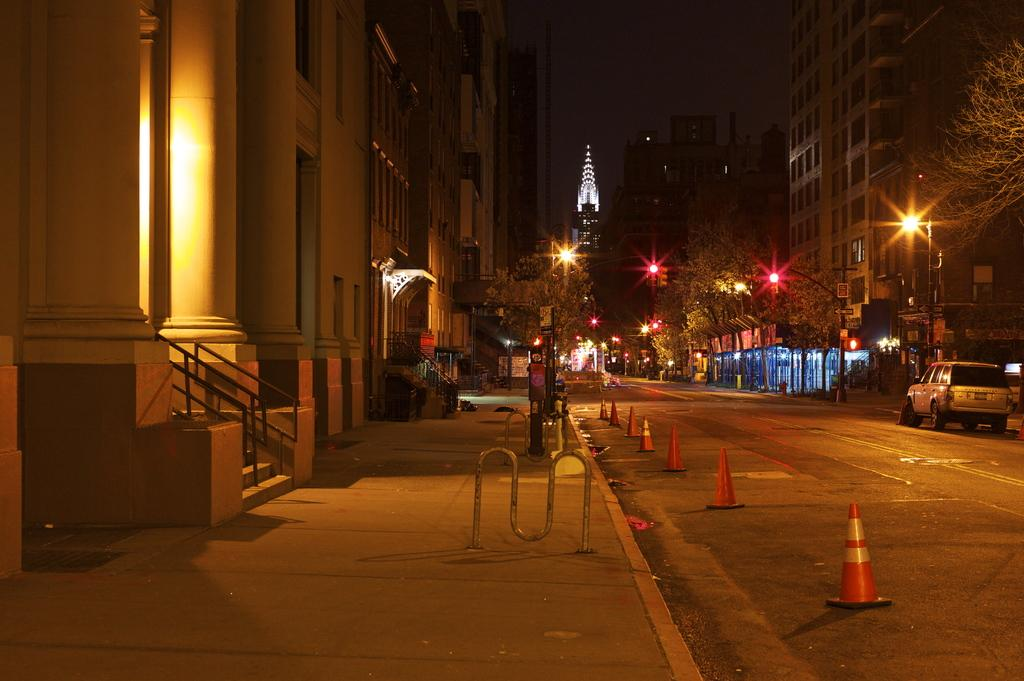What type of structures can be seen in the image? There are buildings in the image. What else is visible in the image besides the buildings? There are lights, road divider cones, a car on the right side, trees in the background, and poles in the background. Where is the car located in the image? The car is on the right side of the image. What can be seen in the distance in the image? There are trees and poles in the background of the image. What type of clam is being served for breakfast in the image? There is no clam or breakfast present in the image; it features buildings, lights, road divider cones, a car, trees, and poles. 